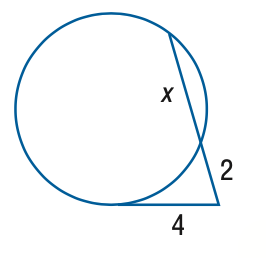Answer the mathemtical geometry problem and directly provide the correct option letter.
Question: Find x to the nearest tenth. Assume that segments that appear to be tangent are tangent.
Choices: A: 2 B: 4 C: 6 D: 8 C 